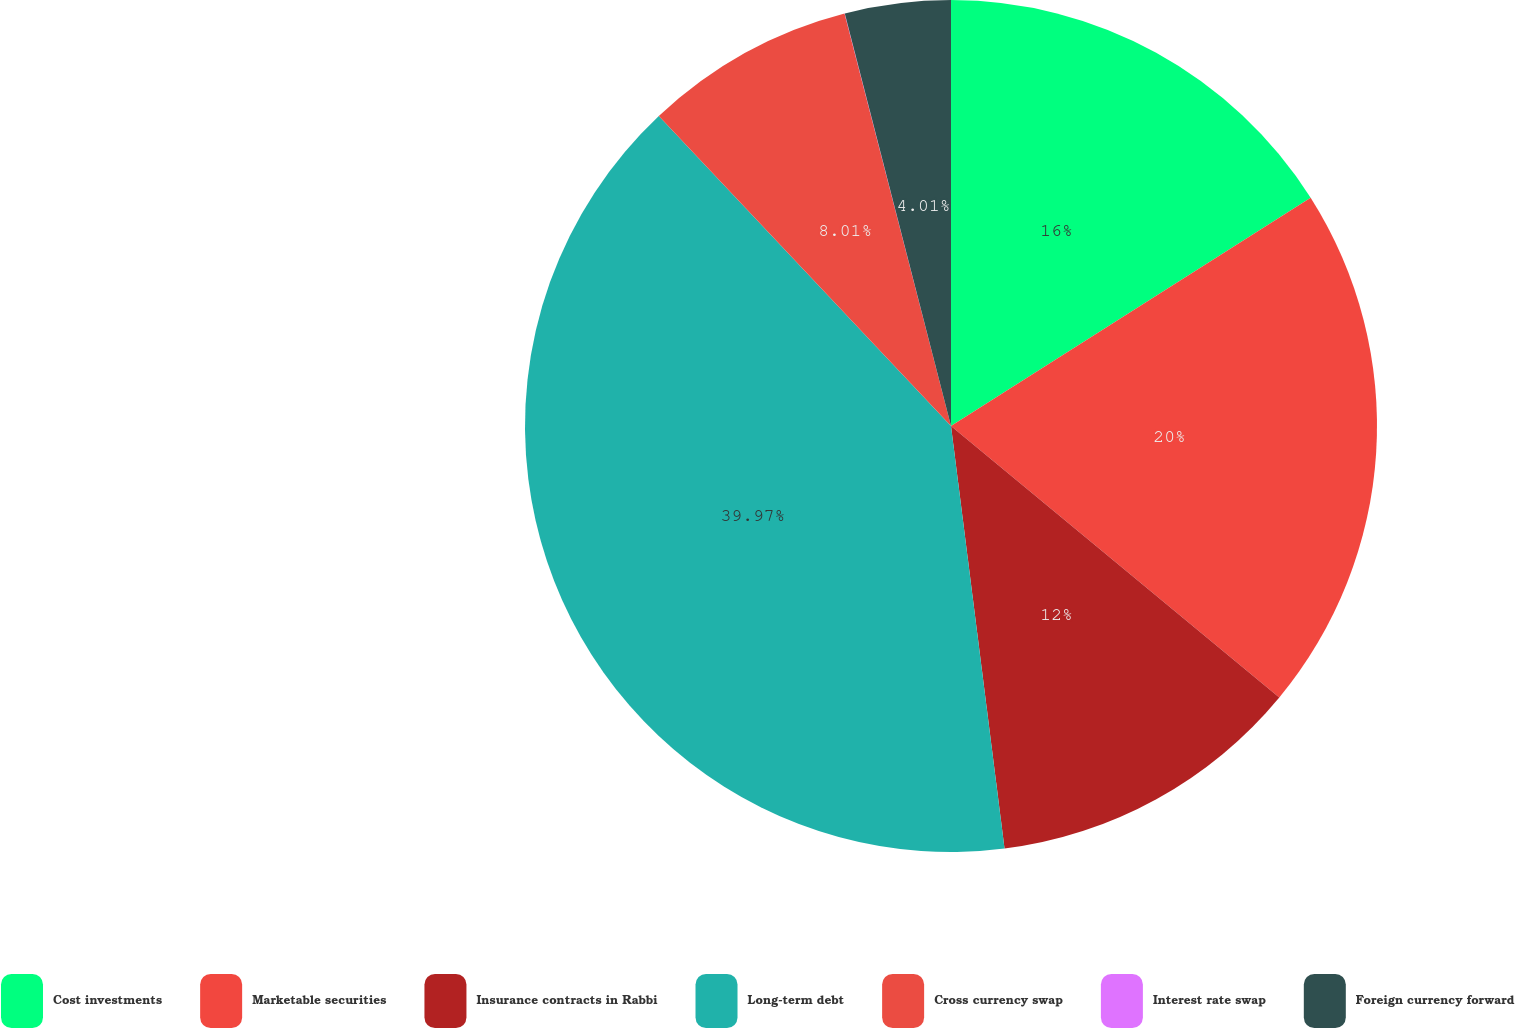Convert chart. <chart><loc_0><loc_0><loc_500><loc_500><pie_chart><fcel>Cost investments<fcel>Marketable securities<fcel>Insurance contracts in Rabbi<fcel>Long-term debt<fcel>Cross currency swap<fcel>Interest rate swap<fcel>Foreign currency forward<nl><fcel>16.0%<fcel>20.0%<fcel>12.0%<fcel>39.98%<fcel>8.01%<fcel>0.01%<fcel>4.01%<nl></chart> 